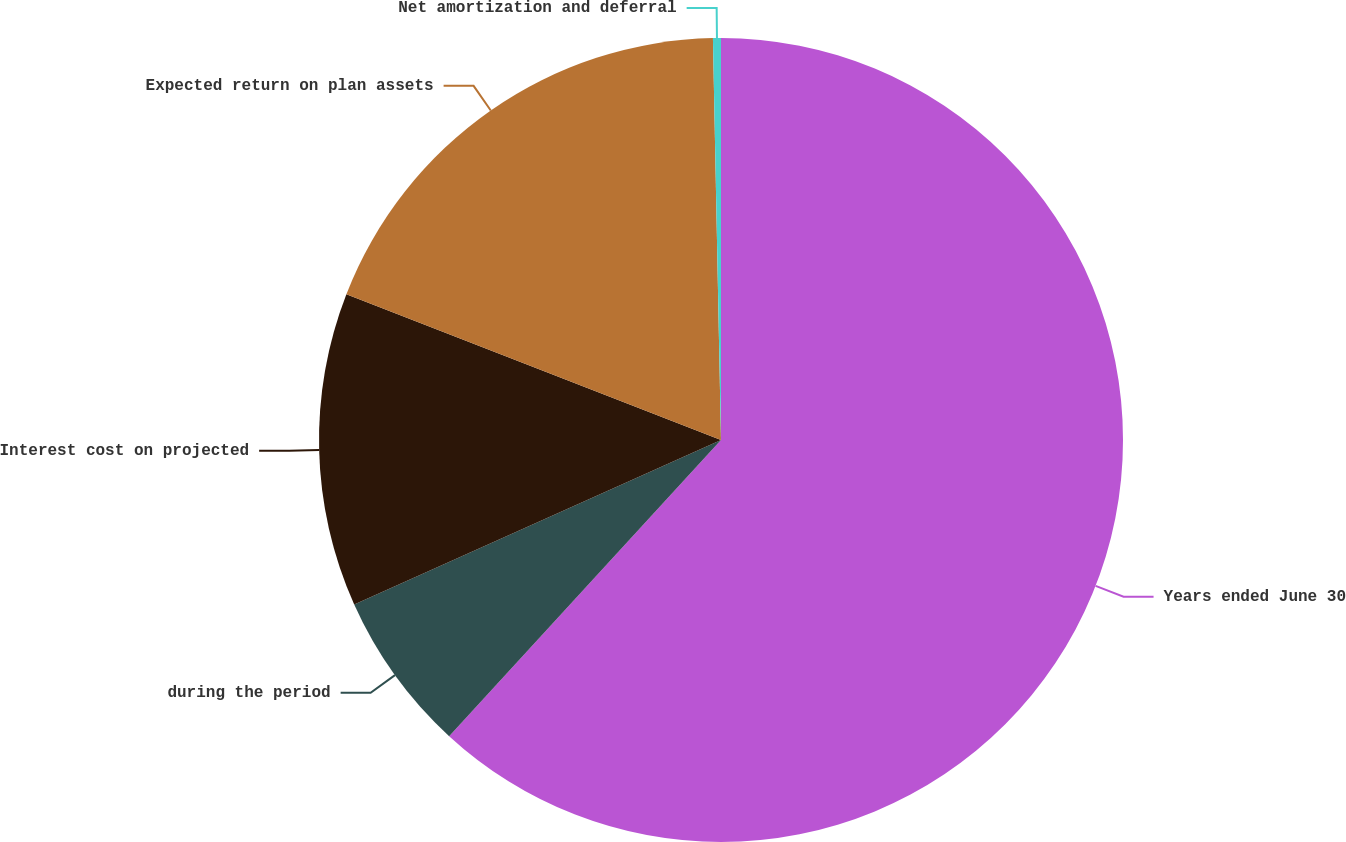Convert chart to OTSL. <chart><loc_0><loc_0><loc_500><loc_500><pie_chart><fcel>Years ended June 30<fcel>during the period<fcel>Interest cost on projected<fcel>Expected return on plan assets<fcel>Net amortization and deferral<nl><fcel>61.82%<fcel>6.47%<fcel>12.62%<fcel>18.77%<fcel>0.32%<nl></chart> 